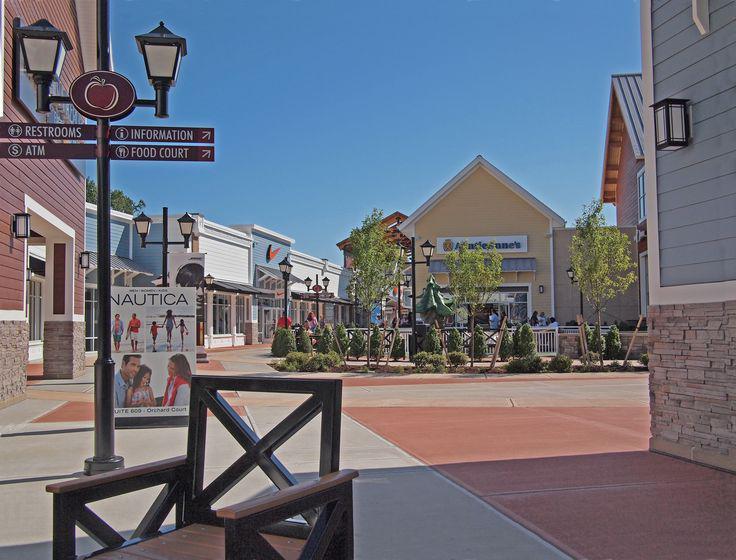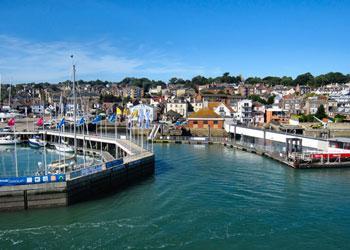The first image is the image on the left, the second image is the image on the right. Assess this claim about the two images: "At least one image shows a harbor and an expanse of water leading into a narrower canal lined with houses and other buildings.". Correct or not? Answer yes or no. Yes. 